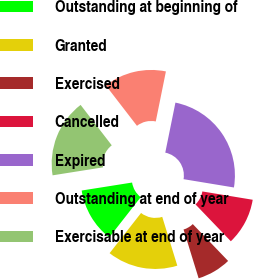<chart> <loc_0><loc_0><loc_500><loc_500><pie_chart><fcel>Outstanding at beginning of<fcel>Granted<fcel>Exercised<fcel>Cancelled<fcel>Expired<fcel>Outstanding at end of year<fcel>Exercisable at end of year<nl><fcel>11.93%<fcel>15.34%<fcel>7.4%<fcel>10.23%<fcel>24.42%<fcel>13.64%<fcel>17.05%<nl></chart> 